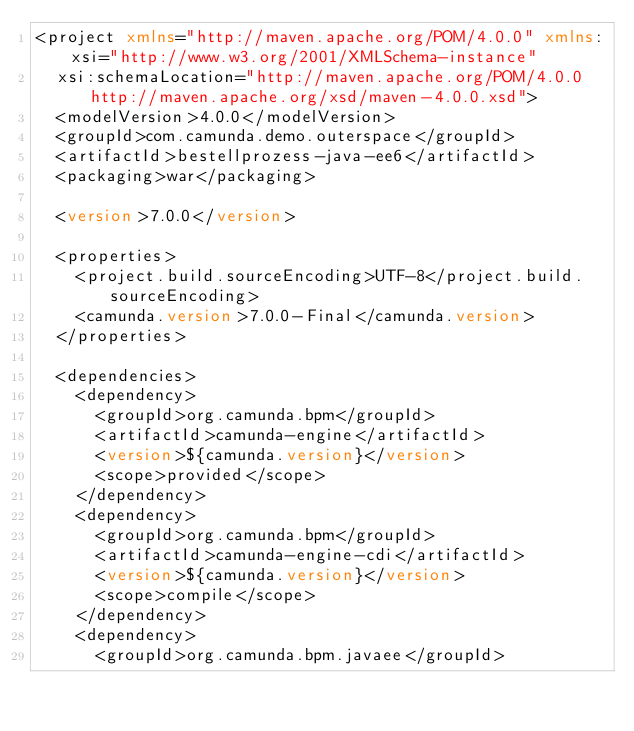Convert code to text. <code><loc_0><loc_0><loc_500><loc_500><_XML_><project xmlns="http://maven.apache.org/POM/4.0.0" xmlns:xsi="http://www.w3.org/2001/XMLSchema-instance"
	xsi:schemaLocation="http://maven.apache.org/POM/4.0.0 http://maven.apache.org/xsd/maven-4.0.0.xsd">
	<modelVersion>4.0.0</modelVersion>
	<groupId>com.camunda.demo.outerspace</groupId>
	<artifactId>bestellprozess-java-ee6</artifactId>
	<packaging>war</packaging>

	<version>7.0.0</version>

	<properties>
		<project.build.sourceEncoding>UTF-8</project.build.sourceEncoding>
		<camunda.version>7.0.0-Final</camunda.version>
	</properties>

	<dependencies>
		<dependency>
			<groupId>org.camunda.bpm</groupId>
			<artifactId>camunda-engine</artifactId>
			<version>${camunda.version}</version>
			<scope>provided</scope>
		</dependency>
		<dependency>
			<groupId>org.camunda.bpm</groupId>
			<artifactId>camunda-engine-cdi</artifactId>
			<version>${camunda.version}</version>
			<scope>compile</scope>
		</dependency>
		<dependency>
			<groupId>org.camunda.bpm.javaee</groupId></code> 